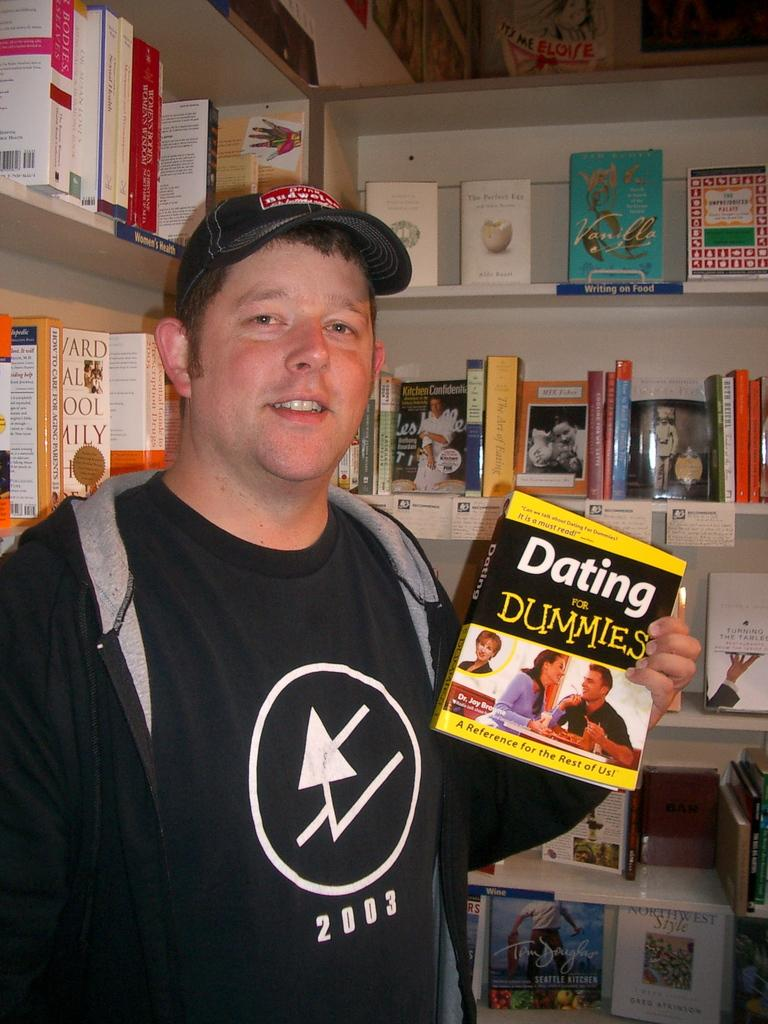<image>
Describe the image concisely. The man in the picture needs dating for dummies. 